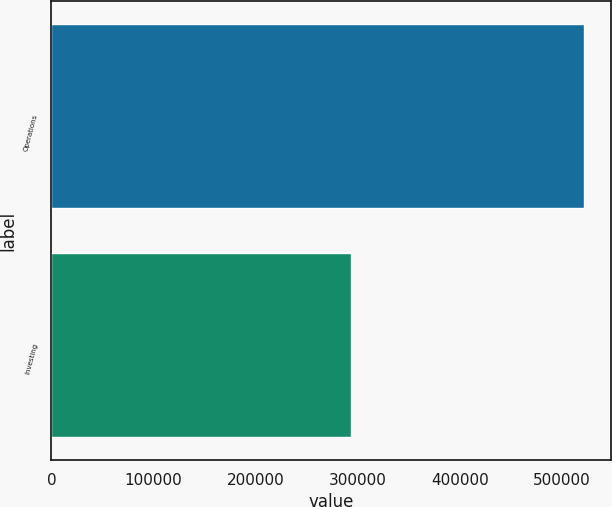Convert chart to OTSL. <chart><loc_0><loc_0><loc_500><loc_500><bar_chart><fcel>Operations<fcel>Investing<nl><fcel>521646<fcel>293711<nl></chart> 